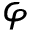<formula> <loc_0><loc_0><loc_500><loc_500>\varphi</formula> 